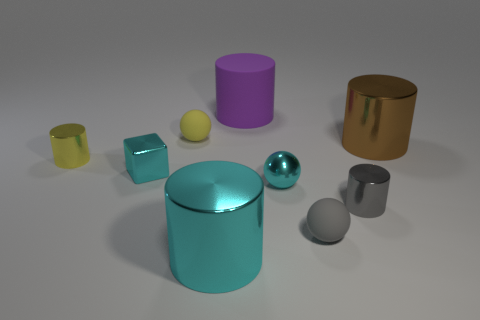Are there more large cyan things behind the small block than cyan metallic blocks right of the purple rubber thing?
Ensure brevity in your answer.  No. What material is the cube that is the same size as the gray matte object?
Give a very brief answer. Metal. How many large things are either purple matte objects or cyan blocks?
Your answer should be compact. 1. Is the large cyan shiny object the same shape as the tiny gray metallic thing?
Ensure brevity in your answer.  Yes. How many small cyan metallic things are both to the right of the tiny cyan metallic block and to the left of the matte cylinder?
Ensure brevity in your answer.  0. Are there any other things that have the same color as the big rubber thing?
Your answer should be very brief. No. There is a gray object that is made of the same material as the tiny yellow cylinder; what is its shape?
Give a very brief answer. Cylinder. Do the yellow rubber ball and the brown cylinder have the same size?
Your response must be concise. No. Is the material of the large thing on the right side of the matte cylinder the same as the block?
Ensure brevity in your answer.  Yes. Is there anything else that is made of the same material as the purple object?
Provide a short and direct response. Yes. 